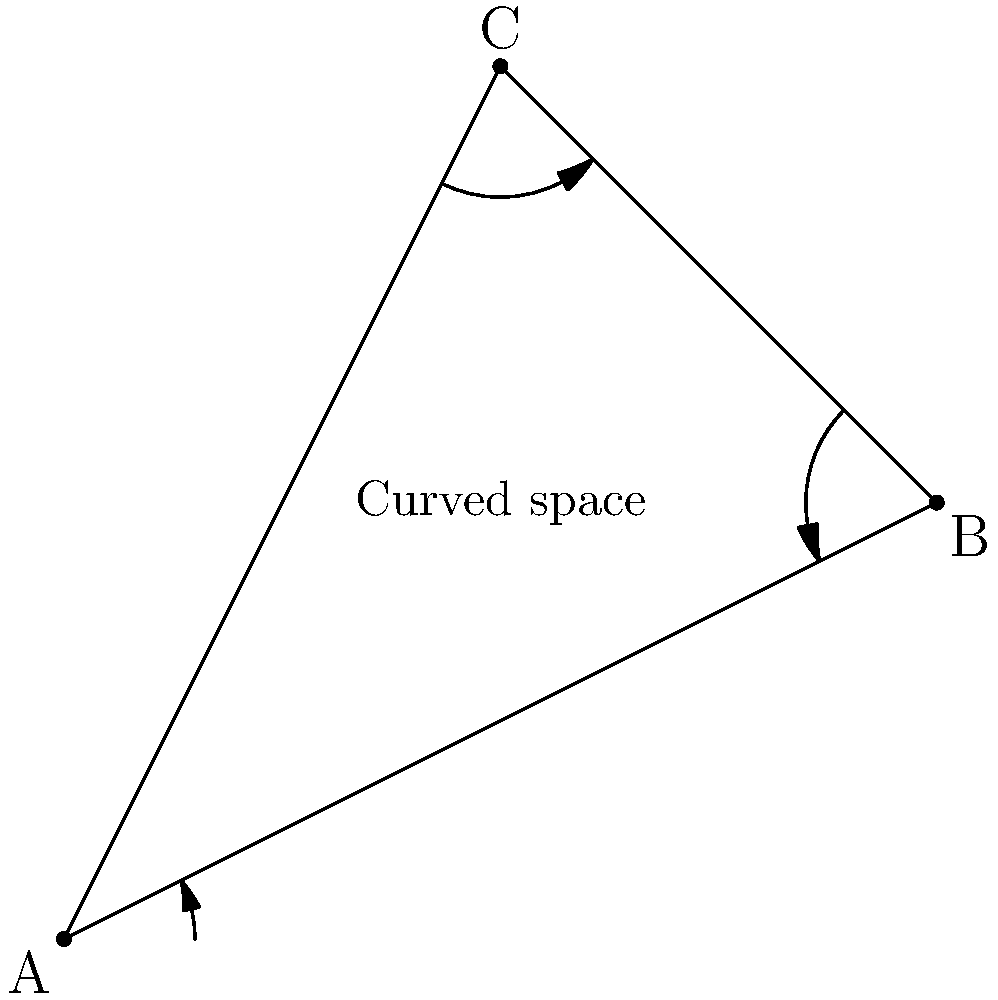In the context of quantum-safe communication networks, consider a Riemannian manifold representing a non-Euclidean space. If the geodesic distance between two points A and B is given by $$d(A,B) = \int_A^B \sqrt{g_{ij}dx^idx^j}$$, where $g_{ij}$ is the metric tensor, how would this affect the implementation of quantum key distribution protocols compared to traditional Euclidean space? To understand the impact of Riemannian geometry on quantum-safe communication networks, let's break down the problem step-by-step:

1. In Riemannian geometry, the distance between two points is measured along curved paths (geodesics) rather than straight lines.

2. The metric tensor $g_{ij}$ determines how distances and angles are measured in the curved space.

3. The geodesic distance formula $$d(A,B) = \int_A^B \sqrt{g_{ij}dx^idx^j}$$ accounts for the curvature of space when calculating distances.

4. In quantum key distribution (QKD) protocols, the security often relies on the ability to detect eavesdropping based on changes in the quantum states of particles.

5. In a non-Euclidean space:
   a) The path taken by quantum particles would follow geodesics, not straight lines.
   b) The distance traveled by particles would be affected by the curvature of space.
   c) The phase of quantum states might be influenced by the geometry of the space.

6. Implementation considerations:
   a) QKD protocols would need to account for the curved nature of space when estimating the expected behavior of quantum particles.
   b) Error rates and security thresholds might need to be adjusted to account for geometric effects.
   c) The choice of basis states for quantum measurements may need to be adapted to the local geometry.

7. Potential advantages:
   a) The curved space might provide additional security by making it harder for an eavesdropper to predict the behavior of quantum states.
   b) The geometry could be used as an additional layer of encryption or authentication.

8. Challenges:
   a) Implementing QKD in non-Euclidean space would require more complex calculations and modeling.
   b) Calibration of quantum devices would need to account for the local geometry at each point in the network.
Answer: QKD protocols must account for geodesic paths, adjust error rates and security thresholds, and adapt basis states to local geometry in non-Euclidean space. 